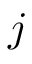Convert formula to latex. <formula><loc_0><loc_0><loc_500><loc_500>j</formula> 